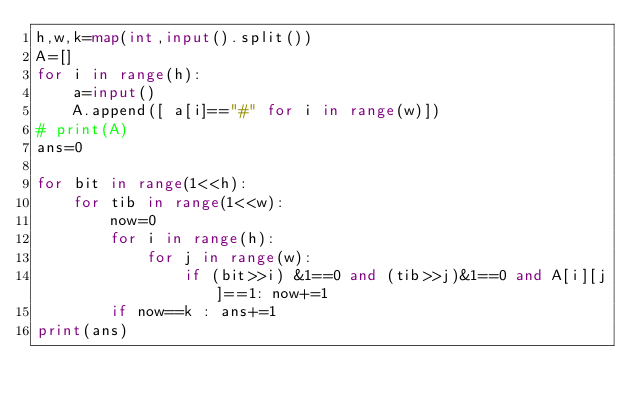<code> <loc_0><loc_0><loc_500><loc_500><_Python_>h,w,k=map(int,input().split())
A=[]
for i in range(h):
    a=input()
    A.append([ a[i]=="#" for i in range(w)])
# print(A)
ans=0

for bit in range(1<<h):
    for tib in range(1<<w):
        now=0
        for i in range(h):
            for j in range(w):
                if (bit>>i) &1==0 and (tib>>j)&1==0 and A[i][j]==1: now+=1
        if now==k : ans+=1
print(ans)</code> 